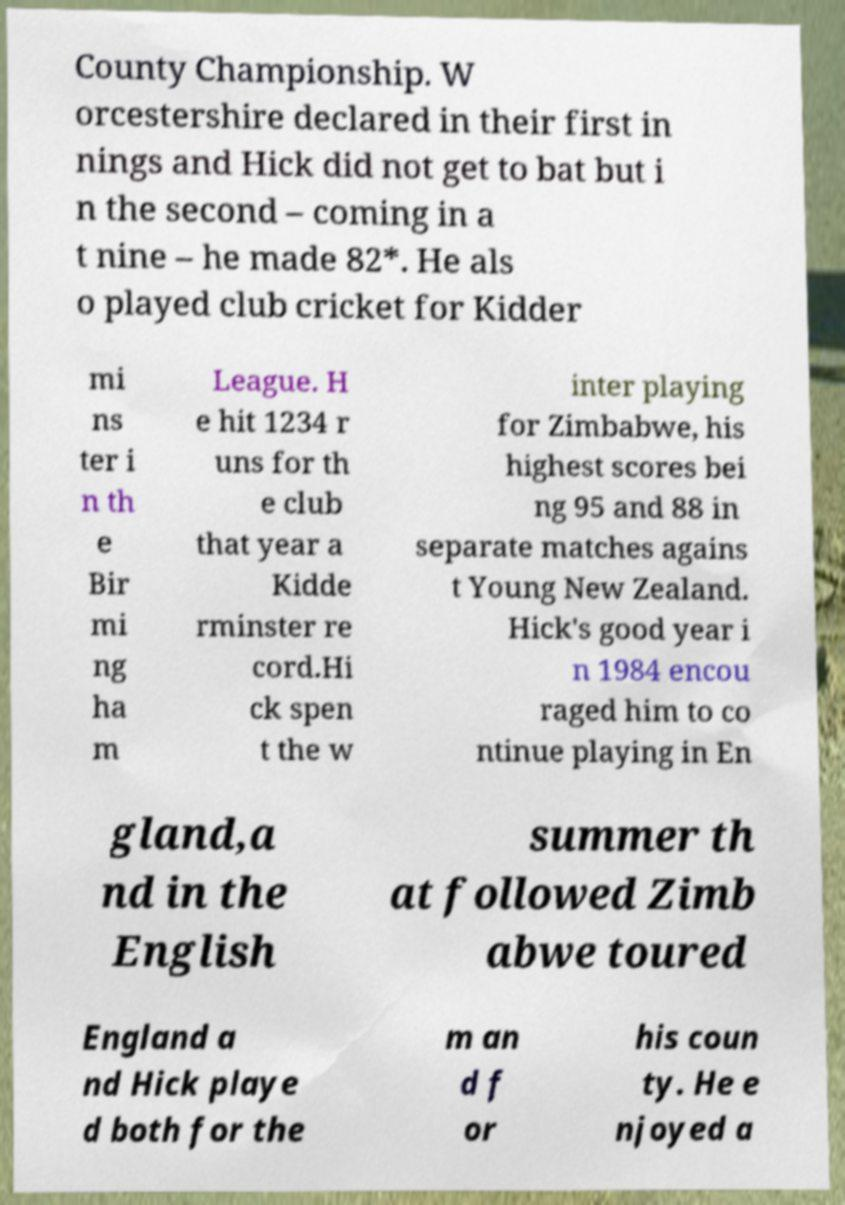Please identify and transcribe the text found in this image. County Championship. W orcestershire declared in their first in nings and Hick did not get to bat but i n the second – coming in a t nine – he made 82*. He als o played club cricket for Kidder mi ns ter i n th e Bir mi ng ha m League. H e hit 1234 r uns for th e club that year a Kidde rminster re cord.Hi ck spen t the w inter playing for Zimbabwe, his highest scores bei ng 95 and 88 in separate matches agains t Young New Zealand. Hick's good year i n 1984 encou raged him to co ntinue playing in En gland,a nd in the English summer th at followed Zimb abwe toured England a nd Hick playe d both for the m an d f or his coun ty. He e njoyed a 